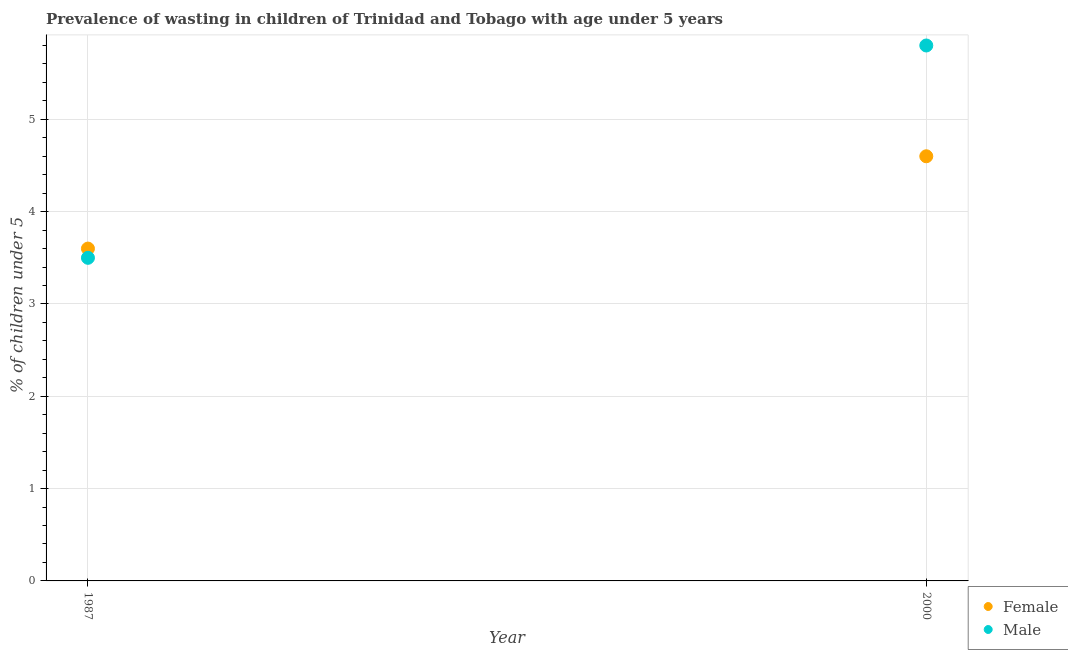How many different coloured dotlines are there?
Offer a terse response. 2. Is the number of dotlines equal to the number of legend labels?
Make the answer very short. Yes. What is the percentage of undernourished female children in 2000?
Make the answer very short. 4.6. Across all years, what is the maximum percentage of undernourished female children?
Offer a very short reply. 4.6. Across all years, what is the minimum percentage of undernourished male children?
Provide a short and direct response. 3.5. In which year was the percentage of undernourished female children maximum?
Ensure brevity in your answer.  2000. In which year was the percentage of undernourished female children minimum?
Ensure brevity in your answer.  1987. What is the total percentage of undernourished male children in the graph?
Provide a short and direct response. 9.3. What is the difference between the percentage of undernourished male children in 1987 and that in 2000?
Your answer should be compact. -2.3. What is the difference between the percentage of undernourished female children in 1987 and the percentage of undernourished male children in 2000?
Offer a terse response. -2.2. What is the average percentage of undernourished female children per year?
Your answer should be compact. 4.1. In the year 2000, what is the difference between the percentage of undernourished female children and percentage of undernourished male children?
Ensure brevity in your answer.  -1.2. What is the ratio of the percentage of undernourished male children in 1987 to that in 2000?
Your response must be concise. 0.6. In how many years, is the percentage of undernourished female children greater than the average percentage of undernourished female children taken over all years?
Make the answer very short. 1. Does the percentage of undernourished male children monotonically increase over the years?
Your response must be concise. Yes. Is the percentage of undernourished female children strictly greater than the percentage of undernourished male children over the years?
Provide a succinct answer. No. How many dotlines are there?
Offer a terse response. 2. What is the difference between two consecutive major ticks on the Y-axis?
Give a very brief answer. 1. Are the values on the major ticks of Y-axis written in scientific E-notation?
Offer a very short reply. No. Does the graph contain any zero values?
Offer a very short reply. No. How many legend labels are there?
Provide a succinct answer. 2. What is the title of the graph?
Provide a succinct answer. Prevalence of wasting in children of Trinidad and Tobago with age under 5 years. Does "State government" appear as one of the legend labels in the graph?
Your answer should be very brief. No. What is the label or title of the Y-axis?
Make the answer very short.  % of children under 5. What is the  % of children under 5 of Female in 1987?
Your answer should be very brief. 3.6. What is the  % of children under 5 in Male in 1987?
Your response must be concise. 3.5. What is the  % of children under 5 of Female in 2000?
Offer a terse response. 4.6. What is the  % of children under 5 of Male in 2000?
Provide a succinct answer. 5.8. Across all years, what is the maximum  % of children under 5 in Female?
Give a very brief answer. 4.6. Across all years, what is the maximum  % of children under 5 of Male?
Your answer should be compact. 5.8. Across all years, what is the minimum  % of children under 5 of Female?
Offer a very short reply. 3.6. Across all years, what is the minimum  % of children under 5 of Male?
Offer a very short reply. 3.5. What is the total  % of children under 5 in Male in the graph?
Your response must be concise. 9.3. What is the difference between the  % of children under 5 in Male in 1987 and that in 2000?
Keep it short and to the point. -2.3. What is the difference between the  % of children under 5 in Female in 1987 and the  % of children under 5 in Male in 2000?
Provide a short and direct response. -2.2. What is the average  % of children under 5 of Female per year?
Give a very brief answer. 4.1. What is the average  % of children under 5 in Male per year?
Give a very brief answer. 4.65. In the year 2000, what is the difference between the  % of children under 5 of Female and  % of children under 5 of Male?
Ensure brevity in your answer.  -1.2. What is the ratio of the  % of children under 5 of Female in 1987 to that in 2000?
Your answer should be compact. 0.78. What is the ratio of the  % of children under 5 of Male in 1987 to that in 2000?
Your response must be concise. 0.6. What is the difference between the highest and the second highest  % of children under 5 of Male?
Provide a short and direct response. 2.3. What is the difference between the highest and the lowest  % of children under 5 of Female?
Provide a short and direct response. 1. What is the difference between the highest and the lowest  % of children under 5 of Male?
Your response must be concise. 2.3. 